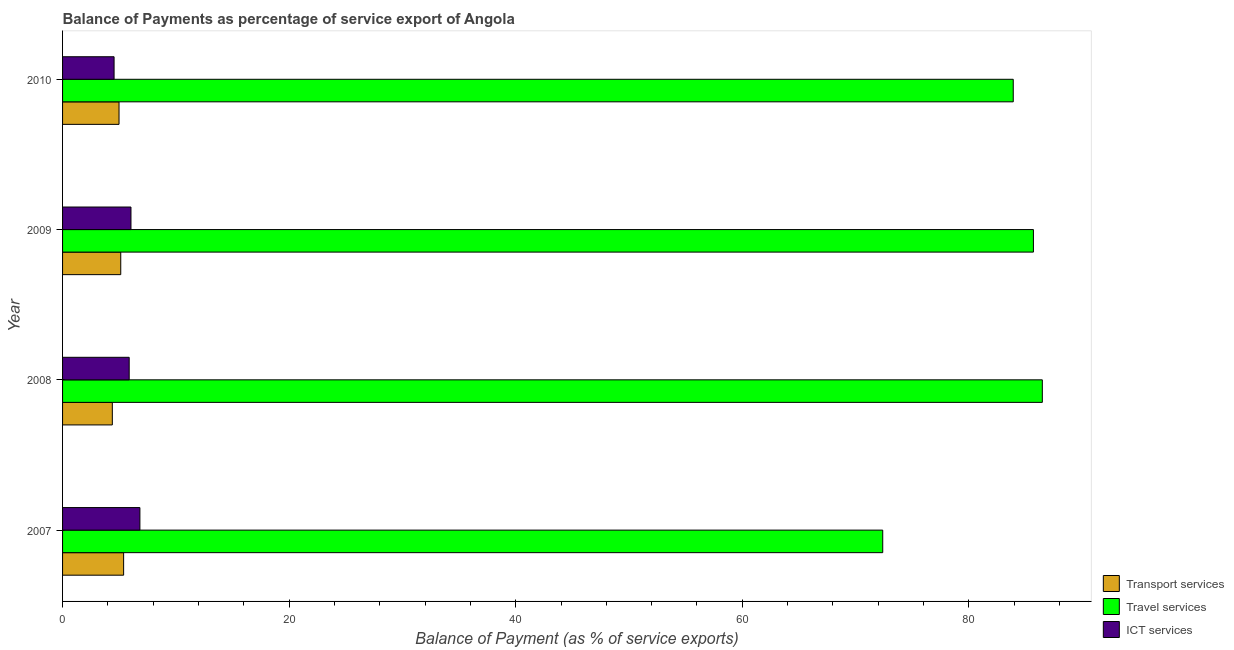How many different coloured bars are there?
Make the answer very short. 3. How many groups of bars are there?
Offer a very short reply. 4. Are the number of bars on each tick of the Y-axis equal?
Keep it short and to the point. Yes. How many bars are there on the 1st tick from the top?
Provide a succinct answer. 3. How many bars are there on the 2nd tick from the bottom?
Make the answer very short. 3. What is the label of the 4th group of bars from the top?
Offer a terse response. 2007. In how many cases, is the number of bars for a given year not equal to the number of legend labels?
Keep it short and to the point. 0. What is the balance of payment of ict services in 2010?
Provide a short and direct response. 4.55. Across all years, what is the maximum balance of payment of travel services?
Offer a very short reply. 86.48. Across all years, what is the minimum balance of payment of travel services?
Your answer should be very brief. 72.4. In which year was the balance of payment of ict services minimum?
Ensure brevity in your answer.  2010. What is the total balance of payment of transport services in the graph?
Provide a succinct answer. 19.9. What is the difference between the balance of payment of transport services in 2008 and that in 2009?
Your answer should be very brief. -0.74. What is the difference between the balance of payment of ict services in 2009 and the balance of payment of travel services in 2008?
Your response must be concise. -80.45. What is the average balance of payment of travel services per year?
Your answer should be very brief. 82.12. In the year 2010, what is the difference between the balance of payment of travel services and balance of payment of ict services?
Your answer should be compact. 79.37. Is the balance of payment of transport services in 2008 less than that in 2010?
Provide a succinct answer. Yes. What is the difference between the highest and the second highest balance of payment of ict services?
Provide a short and direct response. 0.79. What is the difference between the highest and the lowest balance of payment of ict services?
Your answer should be compact. 2.28. In how many years, is the balance of payment of travel services greater than the average balance of payment of travel services taken over all years?
Your response must be concise. 3. What does the 3rd bar from the top in 2008 represents?
Offer a very short reply. Transport services. What does the 2nd bar from the bottom in 2007 represents?
Your response must be concise. Travel services. Is it the case that in every year, the sum of the balance of payment of transport services and balance of payment of travel services is greater than the balance of payment of ict services?
Your response must be concise. Yes. How many years are there in the graph?
Give a very brief answer. 4. Does the graph contain any zero values?
Ensure brevity in your answer.  No. Does the graph contain grids?
Give a very brief answer. No. Where does the legend appear in the graph?
Your response must be concise. Bottom right. How many legend labels are there?
Your response must be concise. 3. How are the legend labels stacked?
Your answer should be compact. Vertical. What is the title of the graph?
Your answer should be very brief. Balance of Payments as percentage of service export of Angola. What is the label or title of the X-axis?
Make the answer very short. Balance of Payment (as % of service exports). What is the Balance of Payment (as % of service exports) in Transport services in 2007?
Offer a very short reply. 5.39. What is the Balance of Payment (as % of service exports) in Travel services in 2007?
Provide a short and direct response. 72.4. What is the Balance of Payment (as % of service exports) of ICT services in 2007?
Make the answer very short. 6.83. What is the Balance of Payment (as % of service exports) in Transport services in 2008?
Offer a terse response. 4.39. What is the Balance of Payment (as % of service exports) in Travel services in 2008?
Keep it short and to the point. 86.48. What is the Balance of Payment (as % of service exports) of ICT services in 2008?
Offer a very short reply. 5.88. What is the Balance of Payment (as % of service exports) of Transport services in 2009?
Provide a short and direct response. 5.14. What is the Balance of Payment (as % of service exports) of Travel services in 2009?
Offer a very short reply. 85.7. What is the Balance of Payment (as % of service exports) of ICT services in 2009?
Provide a succinct answer. 6.04. What is the Balance of Payment (as % of service exports) in Transport services in 2010?
Your response must be concise. 4.98. What is the Balance of Payment (as % of service exports) in Travel services in 2010?
Ensure brevity in your answer.  83.92. What is the Balance of Payment (as % of service exports) in ICT services in 2010?
Offer a terse response. 4.55. Across all years, what is the maximum Balance of Payment (as % of service exports) in Transport services?
Provide a short and direct response. 5.39. Across all years, what is the maximum Balance of Payment (as % of service exports) in Travel services?
Your response must be concise. 86.48. Across all years, what is the maximum Balance of Payment (as % of service exports) in ICT services?
Ensure brevity in your answer.  6.83. Across all years, what is the minimum Balance of Payment (as % of service exports) in Transport services?
Provide a succinct answer. 4.39. Across all years, what is the minimum Balance of Payment (as % of service exports) of Travel services?
Your answer should be compact. 72.4. Across all years, what is the minimum Balance of Payment (as % of service exports) of ICT services?
Make the answer very short. 4.55. What is the total Balance of Payment (as % of service exports) in Transport services in the graph?
Your answer should be compact. 19.9. What is the total Balance of Payment (as % of service exports) of Travel services in the graph?
Provide a short and direct response. 328.5. What is the total Balance of Payment (as % of service exports) of ICT services in the graph?
Keep it short and to the point. 23.29. What is the difference between the Balance of Payment (as % of service exports) of Travel services in 2007 and that in 2008?
Your answer should be compact. -14.09. What is the difference between the Balance of Payment (as % of service exports) of ICT services in 2007 and that in 2008?
Your answer should be very brief. 0.95. What is the difference between the Balance of Payment (as % of service exports) of Transport services in 2007 and that in 2009?
Make the answer very short. 0.25. What is the difference between the Balance of Payment (as % of service exports) of Travel services in 2007 and that in 2009?
Keep it short and to the point. -13.3. What is the difference between the Balance of Payment (as % of service exports) in ICT services in 2007 and that in 2009?
Offer a very short reply. 0.79. What is the difference between the Balance of Payment (as % of service exports) of Transport services in 2007 and that in 2010?
Your answer should be compact. 0.41. What is the difference between the Balance of Payment (as % of service exports) in Travel services in 2007 and that in 2010?
Provide a short and direct response. -11.52. What is the difference between the Balance of Payment (as % of service exports) of ICT services in 2007 and that in 2010?
Your response must be concise. 2.28. What is the difference between the Balance of Payment (as % of service exports) of Transport services in 2008 and that in 2009?
Ensure brevity in your answer.  -0.74. What is the difference between the Balance of Payment (as % of service exports) in Travel services in 2008 and that in 2009?
Offer a terse response. 0.79. What is the difference between the Balance of Payment (as % of service exports) in ICT services in 2008 and that in 2009?
Offer a terse response. -0.16. What is the difference between the Balance of Payment (as % of service exports) of Transport services in 2008 and that in 2010?
Keep it short and to the point. -0.59. What is the difference between the Balance of Payment (as % of service exports) of Travel services in 2008 and that in 2010?
Make the answer very short. 2.57. What is the difference between the Balance of Payment (as % of service exports) of ICT services in 2008 and that in 2010?
Provide a succinct answer. 1.33. What is the difference between the Balance of Payment (as % of service exports) of Transport services in 2009 and that in 2010?
Offer a very short reply. 0.15. What is the difference between the Balance of Payment (as % of service exports) of Travel services in 2009 and that in 2010?
Provide a short and direct response. 1.78. What is the difference between the Balance of Payment (as % of service exports) in ICT services in 2009 and that in 2010?
Provide a short and direct response. 1.49. What is the difference between the Balance of Payment (as % of service exports) in Transport services in 2007 and the Balance of Payment (as % of service exports) in Travel services in 2008?
Your response must be concise. -81.1. What is the difference between the Balance of Payment (as % of service exports) in Transport services in 2007 and the Balance of Payment (as % of service exports) in ICT services in 2008?
Your response must be concise. -0.49. What is the difference between the Balance of Payment (as % of service exports) of Travel services in 2007 and the Balance of Payment (as % of service exports) of ICT services in 2008?
Your response must be concise. 66.52. What is the difference between the Balance of Payment (as % of service exports) of Transport services in 2007 and the Balance of Payment (as % of service exports) of Travel services in 2009?
Keep it short and to the point. -80.31. What is the difference between the Balance of Payment (as % of service exports) of Transport services in 2007 and the Balance of Payment (as % of service exports) of ICT services in 2009?
Your answer should be very brief. -0.65. What is the difference between the Balance of Payment (as % of service exports) of Travel services in 2007 and the Balance of Payment (as % of service exports) of ICT services in 2009?
Offer a very short reply. 66.36. What is the difference between the Balance of Payment (as % of service exports) in Transport services in 2007 and the Balance of Payment (as % of service exports) in Travel services in 2010?
Make the answer very short. -78.53. What is the difference between the Balance of Payment (as % of service exports) in Transport services in 2007 and the Balance of Payment (as % of service exports) in ICT services in 2010?
Give a very brief answer. 0.84. What is the difference between the Balance of Payment (as % of service exports) in Travel services in 2007 and the Balance of Payment (as % of service exports) in ICT services in 2010?
Offer a very short reply. 67.85. What is the difference between the Balance of Payment (as % of service exports) of Transport services in 2008 and the Balance of Payment (as % of service exports) of Travel services in 2009?
Your answer should be very brief. -81.31. What is the difference between the Balance of Payment (as % of service exports) of Transport services in 2008 and the Balance of Payment (as % of service exports) of ICT services in 2009?
Offer a terse response. -1.64. What is the difference between the Balance of Payment (as % of service exports) of Travel services in 2008 and the Balance of Payment (as % of service exports) of ICT services in 2009?
Your answer should be very brief. 80.45. What is the difference between the Balance of Payment (as % of service exports) of Transport services in 2008 and the Balance of Payment (as % of service exports) of Travel services in 2010?
Provide a short and direct response. -79.52. What is the difference between the Balance of Payment (as % of service exports) in Transport services in 2008 and the Balance of Payment (as % of service exports) in ICT services in 2010?
Keep it short and to the point. -0.15. What is the difference between the Balance of Payment (as % of service exports) of Travel services in 2008 and the Balance of Payment (as % of service exports) of ICT services in 2010?
Make the answer very short. 81.94. What is the difference between the Balance of Payment (as % of service exports) of Transport services in 2009 and the Balance of Payment (as % of service exports) of Travel services in 2010?
Ensure brevity in your answer.  -78.78. What is the difference between the Balance of Payment (as % of service exports) of Transport services in 2009 and the Balance of Payment (as % of service exports) of ICT services in 2010?
Your response must be concise. 0.59. What is the difference between the Balance of Payment (as % of service exports) in Travel services in 2009 and the Balance of Payment (as % of service exports) in ICT services in 2010?
Offer a very short reply. 81.15. What is the average Balance of Payment (as % of service exports) in Transport services per year?
Offer a terse response. 4.98. What is the average Balance of Payment (as % of service exports) in Travel services per year?
Ensure brevity in your answer.  82.12. What is the average Balance of Payment (as % of service exports) of ICT services per year?
Keep it short and to the point. 5.82. In the year 2007, what is the difference between the Balance of Payment (as % of service exports) in Transport services and Balance of Payment (as % of service exports) in Travel services?
Ensure brevity in your answer.  -67.01. In the year 2007, what is the difference between the Balance of Payment (as % of service exports) of Transport services and Balance of Payment (as % of service exports) of ICT services?
Your answer should be compact. -1.44. In the year 2007, what is the difference between the Balance of Payment (as % of service exports) in Travel services and Balance of Payment (as % of service exports) in ICT services?
Your answer should be compact. 65.57. In the year 2008, what is the difference between the Balance of Payment (as % of service exports) of Transport services and Balance of Payment (as % of service exports) of Travel services?
Provide a short and direct response. -82.09. In the year 2008, what is the difference between the Balance of Payment (as % of service exports) in Transport services and Balance of Payment (as % of service exports) in ICT services?
Provide a succinct answer. -1.49. In the year 2008, what is the difference between the Balance of Payment (as % of service exports) of Travel services and Balance of Payment (as % of service exports) of ICT services?
Your answer should be compact. 80.6. In the year 2009, what is the difference between the Balance of Payment (as % of service exports) in Transport services and Balance of Payment (as % of service exports) in Travel services?
Provide a short and direct response. -80.56. In the year 2009, what is the difference between the Balance of Payment (as % of service exports) in Transport services and Balance of Payment (as % of service exports) in ICT services?
Make the answer very short. -0.9. In the year 2009, what is the difference between the Balance of Payment (as % of service exports) of Travel services and Balance of Payment (as % of service exports) of ICT services?
Give a very brief answer. 79.66. In the year 2010, what is the difference between the Balance of Payment (as % of service exports) in Transport services and Balance of Payment (as % of service exports) in Travel services?
Keep it short and to the point. -78.93. In the year 2010, what is the difference between the Balance of Payment (as % of service exports) in Transport services and Balance of Payment (as % of service exports) in ICT services?
Give a very brief answer. 0.44. In the year 2010, what is the difference between the Balance of Payment (as % of service exports) of Travel services and Balance of Payment (as % of service exports) of ICT services?
Provide a short and direct response. 79.37. What is the ratio of the Balance of Payment (as % of service exports) of Transport services in 2007 to that in 2008?
Your answer should be compact. 1.23. What is the ratio of the Balance of Payment (as % of service exports) in Travel services in 2007 to that in 2008?
Provide a succinct answer. 0.84. What is the ratio of the Balance of Payment (as % of service exports) of ICT services in 2007 to that in 2008?
Your answer should be compact. 1.16. What is the ratio of the Balance of Payment (as % of service exports) in Transport services in 2007 to that in 2009?
Your answer should be very brief. 1.05. What is the ratio of the Balance of Payment (as % of service exports) of Travel services in 2007 to that in 2009?
Your answer should be compact. 0.84. What is the ratio of the Balance of Payment (as % of service exports) of ICT services in 2007 to that in 2009?
Give a very brief answer. 1.13. What is the ratio of the Balance of Payment (as % of service exports) in Transport services in 2007 to that in 2010?
Your response must be concise. 1.08. What is the ratio of the Balance of Payment (as % of service exports) in Travel services in 2007 to that in 2010?
Offer a terse response. 0.86. What is the ratio of the Balance of Payment (as % of service exports) of ICT services in 2007 to that in 2010?
Give a very brief answer. 1.5. What is the ratio of the Balance of Payment (as % of service exports) in Transport services in 2008 to that in 2009?
Offer a terse response. 0.86. What is the ratio of the Balance of Payment (as % of service exports) in Travel services in 2008 to that in 2009?
Offer a terse response. 1.01. What is the ratio of the Balance of Payment (as % of service exports) in ICT services in 2008 to that in 2009?
Make the answer very short. 0.97. What is the ratio of the Balance of Payment (as % of service exports) of Transport services in 2008 to that in 2010?
Give a very brief answer. 0.88. What is the ratio of the Balance of Payment (as % of service exports) of Travel services in 2008 to that in 2010?
Provide a succinct answer. 1.03. What is the ratio of the Balance of Payment (as % of service exports) in ICT services in 2008 to that in 2010?
Offer a terse response. 1.29. What is the ratio of the Balance of Payment (as % of service exports) of Transport services in 2009 to that in 2010?
Give a very brief answer. 1.03. What is the ratio of the Balance of Payment (as % of service exports) of Travel services in 2009 to that in 2010?
Your response must be concise. 1.02. What is the ratio of the Balance of Payment (as % of service exports) in ICT services in 2009 to that in 2010?
Offer a very short reply. 1.33. What is the difference between the highest and the second highest Balance of Payment (as % of service exports) in Transport services?
Offer a terse response. 0.25. What is the difference between the highest and the second highest Balance of Payment (as % of service exports) in Travel services?
Provide a short and direct response. 0.79. What is the difference between the highest and the second highest Balance of Payment (as % of service exports) of ICT services?
Provide a short and direct response. 0.79. What is the difference between the highest and the lowest Balance of Payment (as % of service exports) in Travel services?
Provide a short and direct response. 14.09. What is the difference between the highest and the lowest Balance of Payment (as % of service exports) in ICT services?
Your response must be concise. 2.28. 